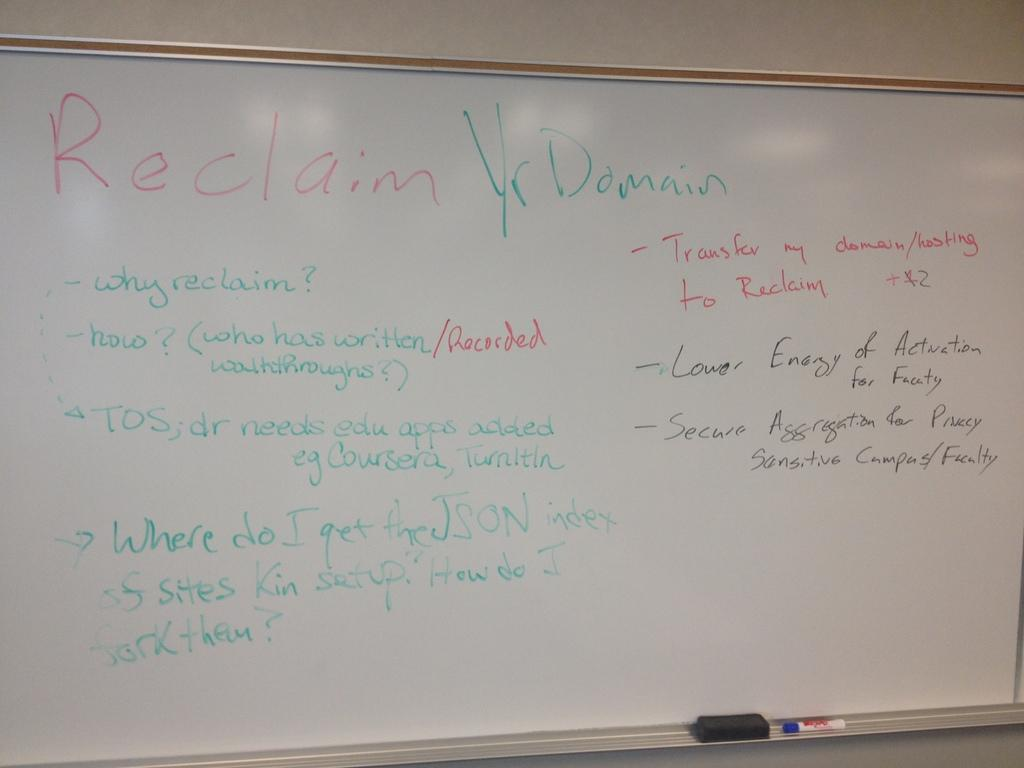<image>
Summarize the visual content of the image. A white board shows notes from a lecture on Reclaiming your Domain 